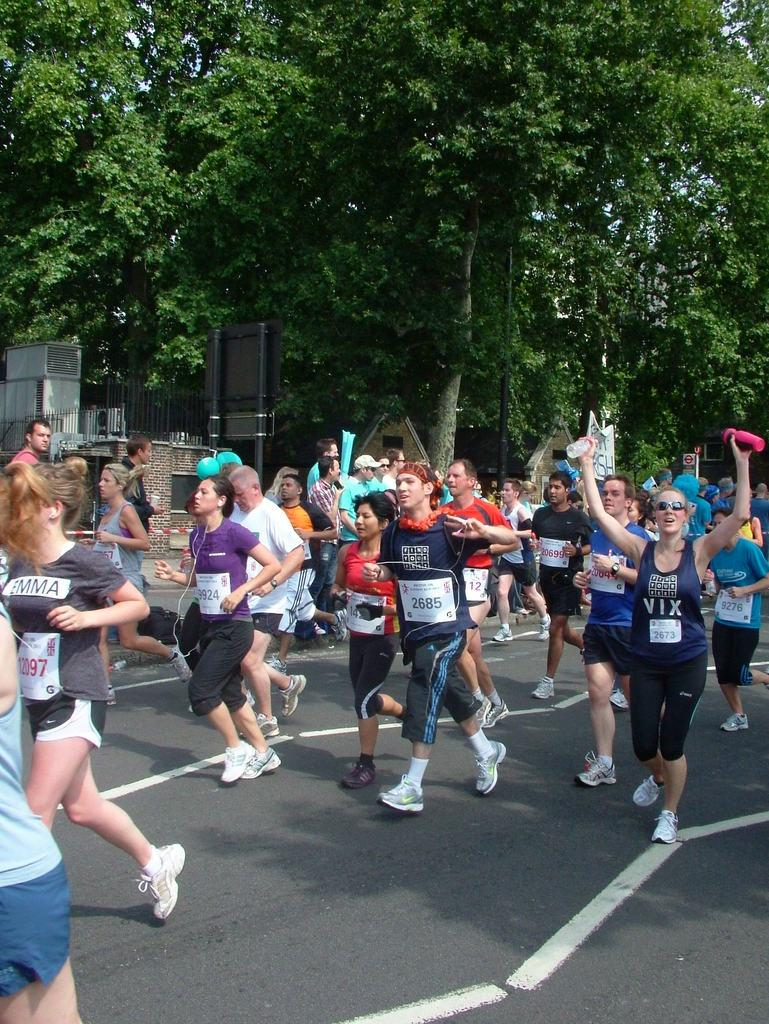What is happening on the road in the image? There is a group of people on the road in the image. Can you describe what one woman is holding? One woman is holding bottles in the image. What can be seen in the distance behind the group of people? There are trees visible in the background, as well as unspecified objects. What type of example is the grandfather giving in the image? There is no grandfather or example present in the image. What type of building can be seen in the background of the image? There is no building visible in the background of the image; only trees and unspecified objects are present. 